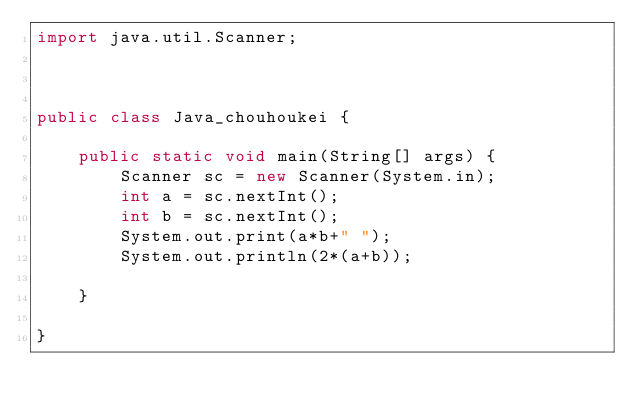Convert code to text. <code><loc_0><loc_0><loc_500><loc_500><_Java_>import java.util.Scanner;



public class Java_chouhoukei {

	public static void main(String[] args) {
		Scanner sc = new Scanner(System.in);
		int a = sc.nextInt();
		int b = sc.nextInt();
		System.out.print(a*b+" ");
		System.out.println(2*(a+b));

	}

}

</code> 